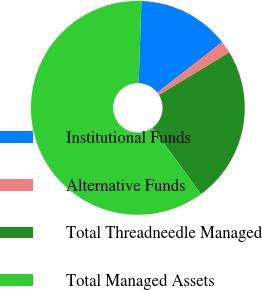<chart> <loc_0><loc_0><loc_500><loc_500><pie_chart><fcel>Institutional Funds<fcel>Alternative Funds<fcel>Total Threadneedle Managed<fcel>Total Managed Assets<nl><fcel>13.94%<fcel>1.86%<fcel>23.61%<fcel>60.59%<nl></chart> 